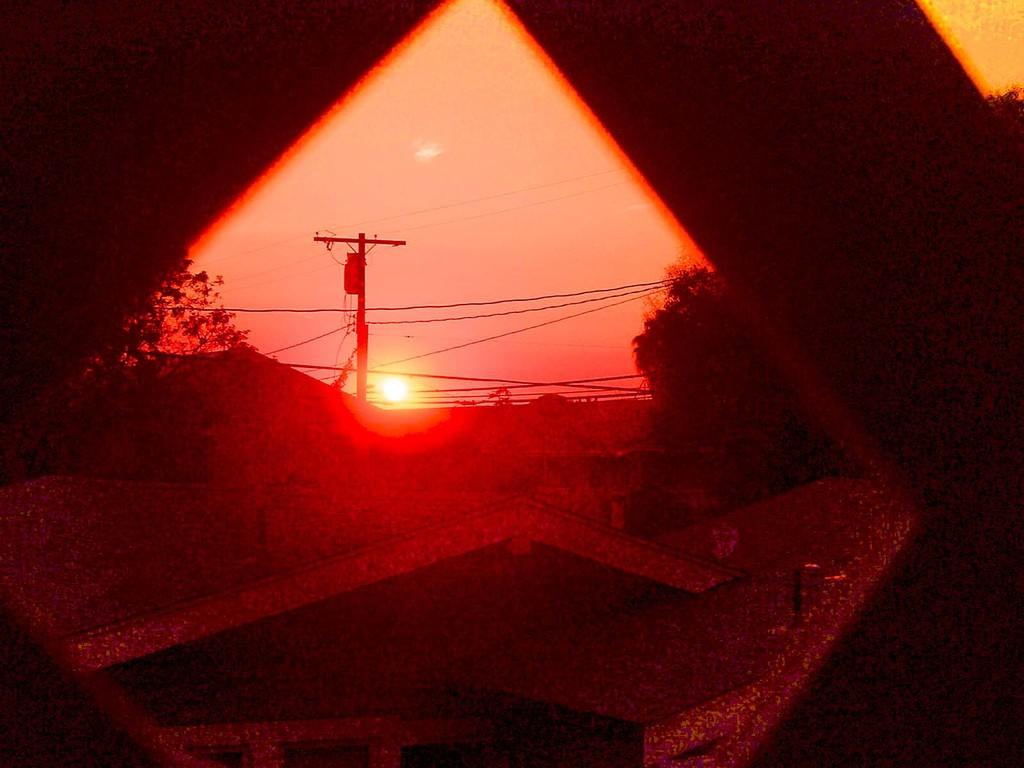What type of vegetation can be seen in the image? There are trees in the image. What else is present in the image besides trees? There are wires and a current pole in the image. What can be seen in the background of the image? The sky is visible in the background of the image. What celestial body is observable in the sky? The sun is observable in the sky. What type of button can be seen on the truck in the image? There is no truck present in the image, so there is no button to observe. What type of plants can be seen growing on the current pole in the image? There are no plants growing on the current pole in the image. 